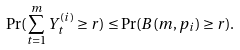Convert formula to latex. <formula><loc_0><loc_0><loc_500><loc_500>\Pr ( \sum _ { t = 1 } ^ { m } Y _ { t } ^ { ( i ) } \geq r ) \leq \Pr ( B ( m , p _ { i } ) \geq r ) .</formula> 